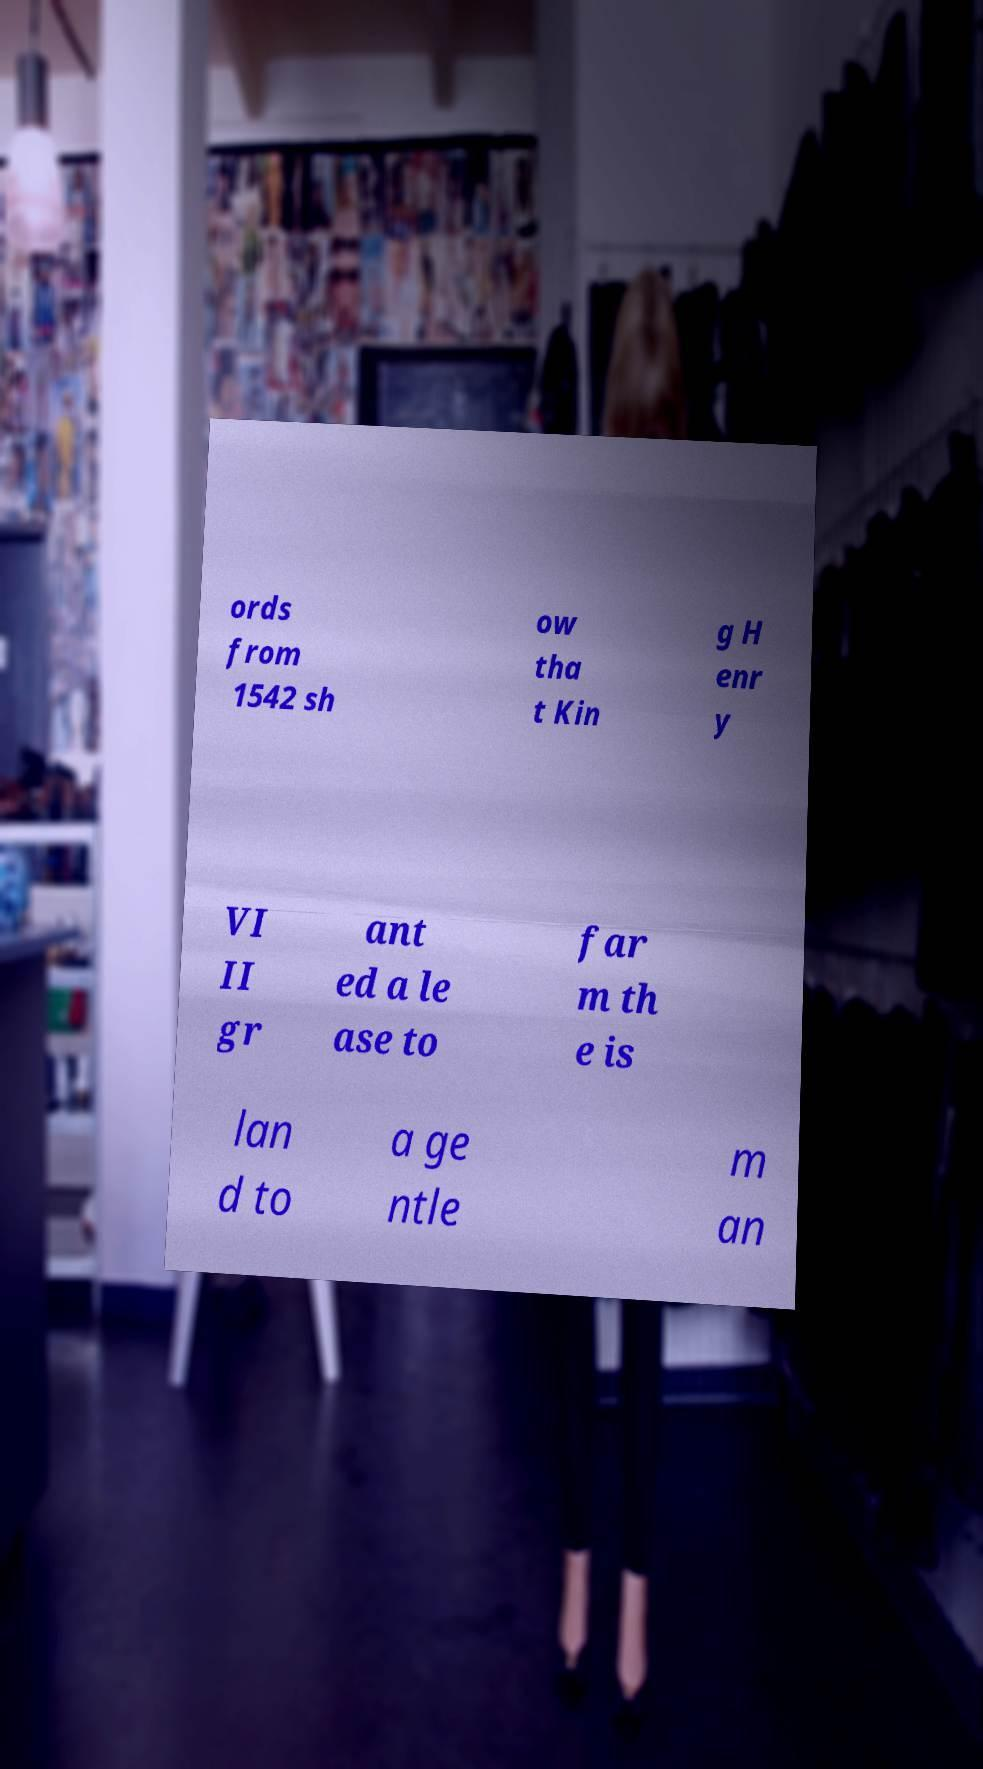For documentation purposes, I need the text within this image transcribed. Could you provide that? ords from 1542 sh ow tha t Kin g H enr y VI II gr ant ed a le ase to far m th e is lan d to a ge ntle m an 